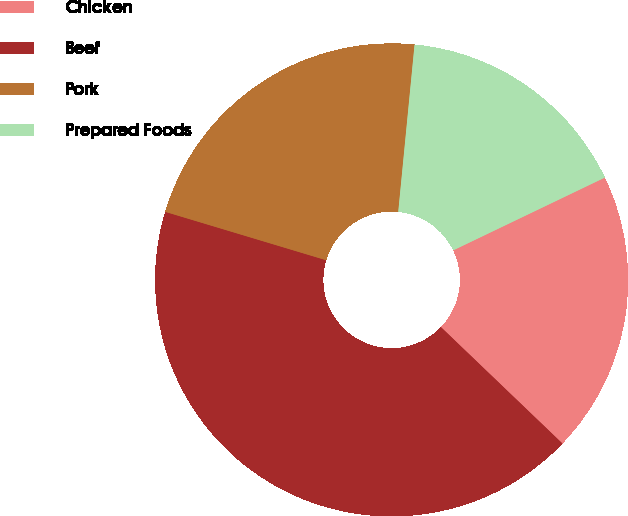Convert chart. <chart><loc_0><loc_0><loc_500><loc_500><pie_chart><fcel>Chicken<fcel>Beef<fcel>Pork<fcel>Prepared Foods<nl><fcel>19.28%<fcel>42.49%<fcel>21.9%<fcel>16.33%<nl></chart> 